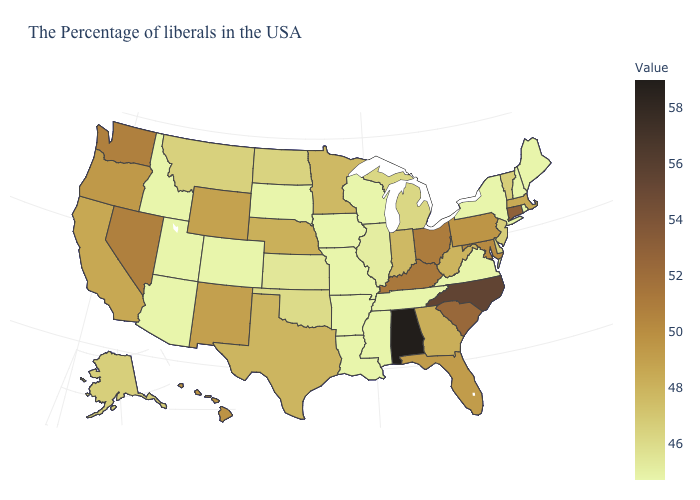Which states hav the highest value in the South?
Quick response, please. Alabama. Does Wyoming have the highest value in the West?
Be succinct. No. 